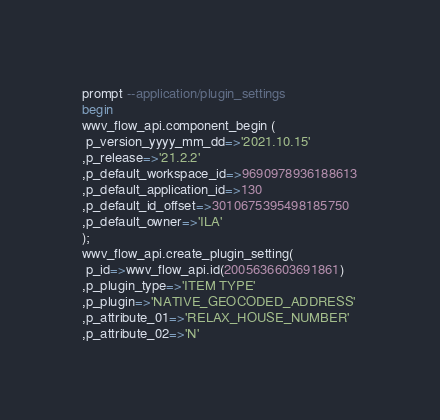Convert code to text. <code><loc_0><loc_0><loc_500><loc_500><_SQL_>prompt --application/plugin_settings
begin
wwv_flow_api.component_begin (
 p_version_yyyy_mm_dd=>'2021.10.15'
,p_release=>'21.2.2'
,p_default_workspace_id=>9690978936188613
,p_default_application_id=>130
,p_default_id_offset=>3010675395498185750
,p_default_owner=>'ILA'
);
wwv_flow_api.create_plugin_setting(
 p_id=>wwv_flow_api.id(2005636603691861)
,p_plugin_type=>'ITEM TYPE'
,p_plugin=>'NATIVE_GEOCODED_ADDRESS'
,p_attribute_01=>'RELAX_HOUSE_NUMBER'
,p_attribute_02=>'N'</code> 